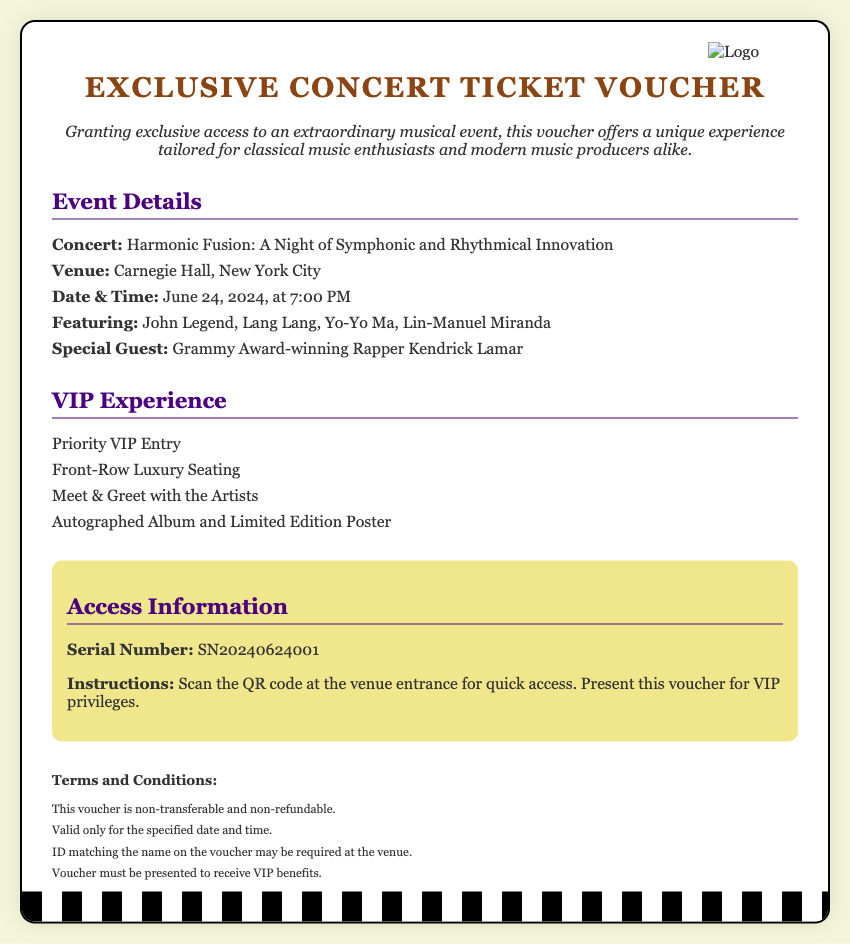What is the name of the concert? The concert name is listed in the document under "Concert," which is "Harmonic Fusion: A Night of Symphonic and Rhythmical Innovation."
Answer: Harmonic Fusion: A Night of Symphonic and Rhythmical Innovation Where is the concert being held? The venue for the concert is specified in the "Venue" section, which states "Carnegie Hall, New York City."
Answer: Carnegie Hall, New York City Who are the main artists performing? The names of the main artists are listed under "Featuring" in the document, including John Legend, Lang Lang, Yo-Yo Ma, and Lin-Manuel Miranda.
Answer: John Legend, Lang Lang, Yo-Yo Ma, Lin-Manuel Miranda What VIP experience is included? The document provides details on the VIP experience, stating benefits like "Priority VIP Entry" and "Meet & Greet with the Artists."
Answer: Priority VIP Entry What is the serial number of the voucher? The serial number is clearly stated in the "Access Information" section, which lists it as "SN20240624001."
Answer: SN20240624001 When is the concert scheduled to take place? The date and time of the concert are indicated in the "Date & Time" section, which shows "June 24, 2024, at 7:00 PM."
Answer: June 24, 2024, at 7:00 PM Is the voucher transferable? The terms specified in the "Terms and Conditions" section mention that "This voucher is non-transferable."
Answer: Non-transferable What must be presented to receive VIP benefits? The document states "Voucher must be presented to receive VIP benefits" in the terms section.
Answer: Voucher 